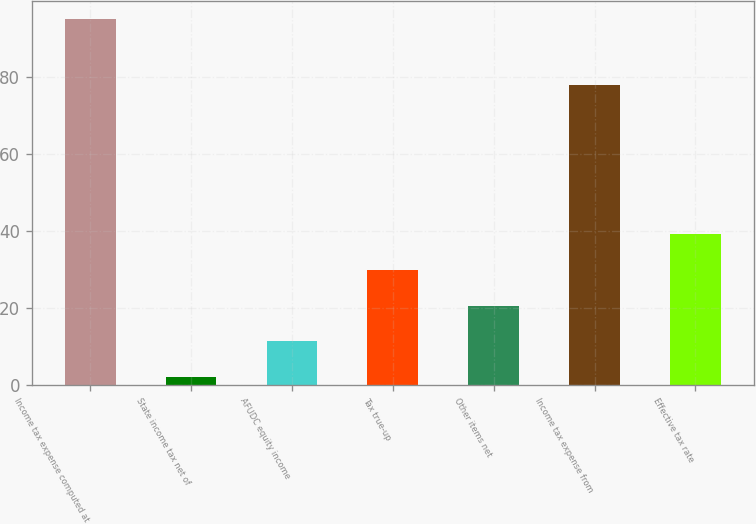Convert chart to OTSL. <chart><loc_0><loc_0><loc_500><loc_500><bar_chart><fcel>Income tax expense computed at<fcel>State income tax net of<fcel>AFUDC equity income<fcel>Tax true-up<fcel>Other items net<fcel>Income tax expense from<fcel>Effective tax rate<nl><fcel>95<fcel>2<fcel>11.3<fcel>29.9<fcel>20.6<fcel>78<fcel>39.2<nl></chart> 